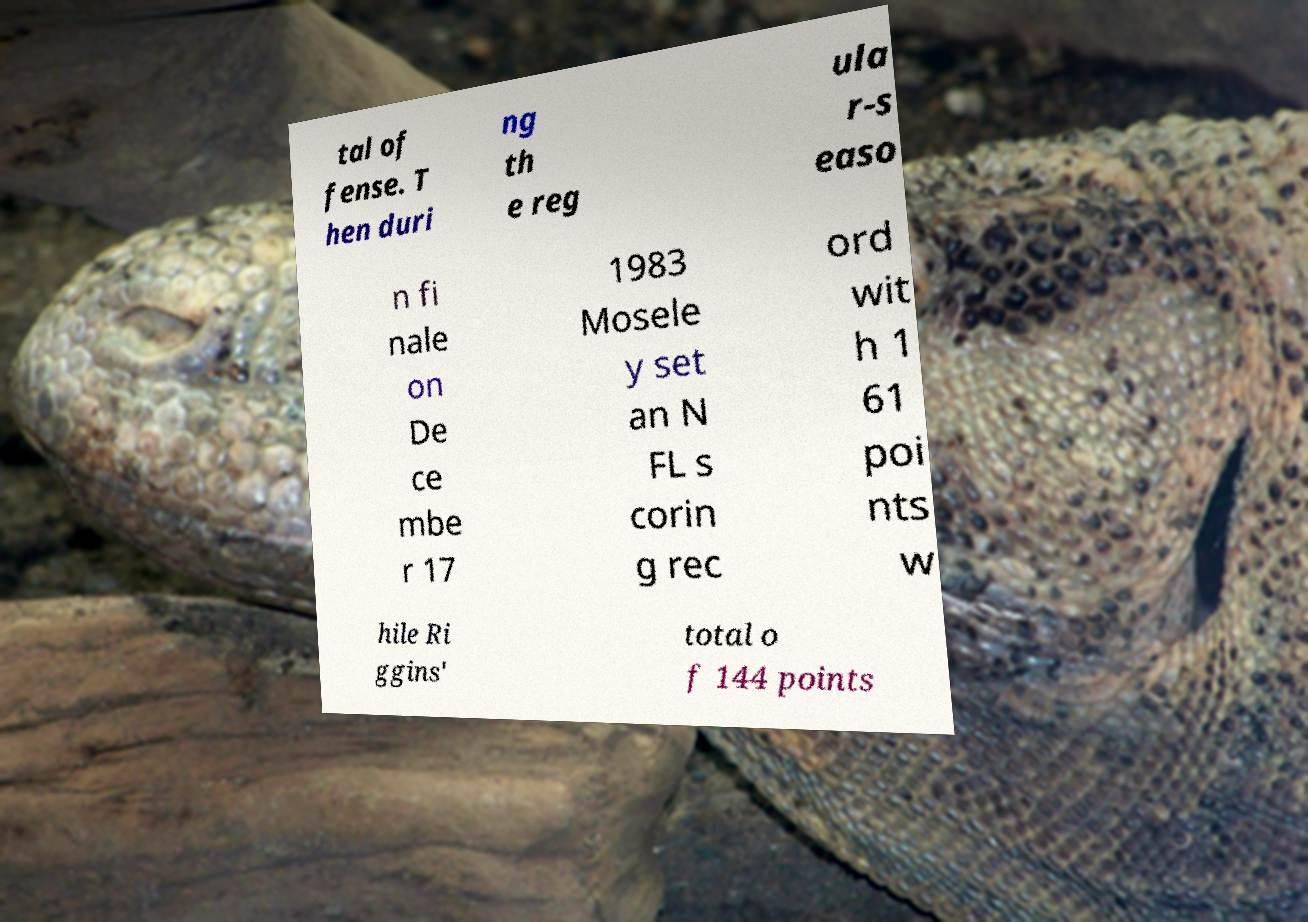I need the written content from this picture converted into text. Can you do that? tal of fense. T hen duri ng th e reg ula r-s easo n fi nale on De ce mbe r 17 1983 Mosele y set an N FL s corin g rec ord wit h 1 61 poi nts w hile Ri ggins' total o f 144 points 